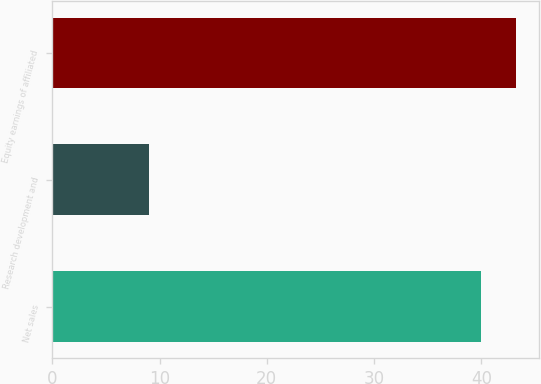Convert chart to OTSL. <chart><loc_0><loc_0><loc_500><loc_500><bar_chart><fcel>Net sales<fcel>Research development and<fcel>Equity earnings of affiliated<nl><fcel>40<fcel>9<fcel>43.2<nl></chart> 